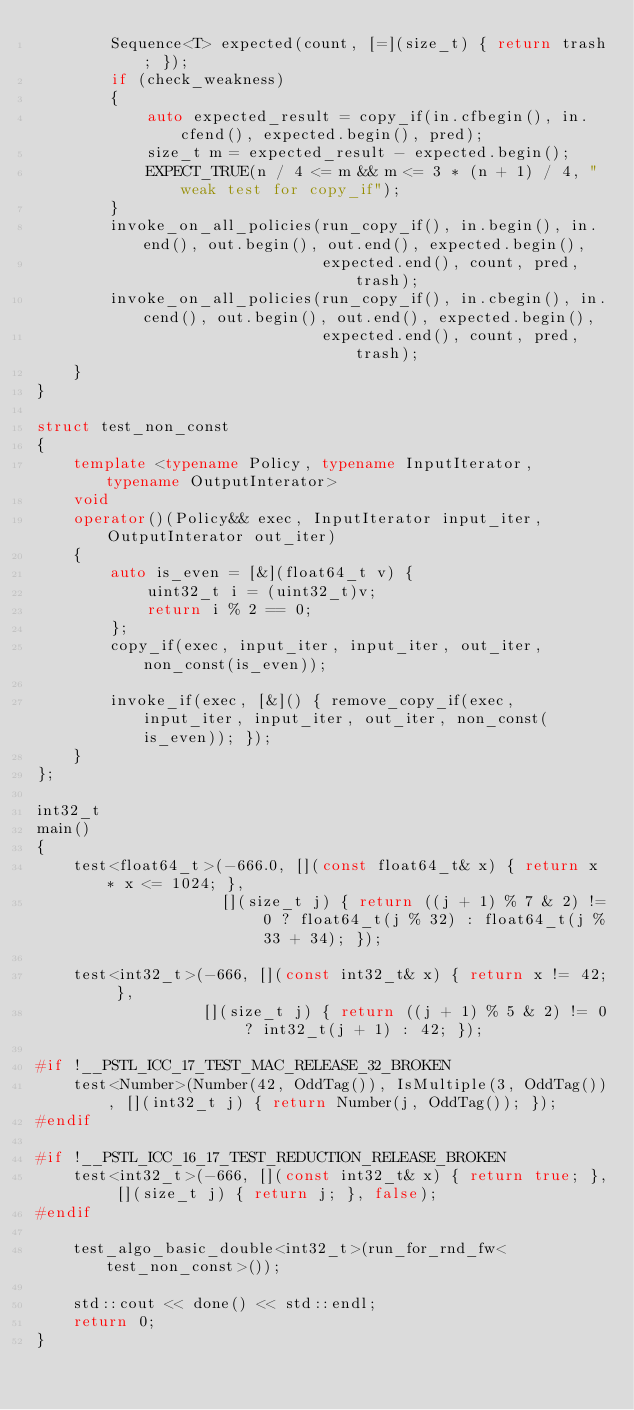<code> <loc_0><loc_0><loc_500><loc_500><_C++_>        Sequence<T> expected(count, [=](size_t) { return trash; });
        if (check_weakness)
        {
            auto expected_result = copy_if(in.cfbegin(), in.cfend(), expected.begin(), pred);
            size_t m = expected_result - expected.begin();
            EXPECT_TRUE(n / 4 <= m && m <= 3 * (n + 1) / 4, "weak test for copy_if");
        }
        invoke_on_all_policies(run_copy_if(), in.begin(), in.end(), out.begin(), out.end(), expected.begin(),
                               expected.end(), count, pred, trash);
        invoke_on_all_policies(run_copy_if(), in.cbegin(), in.cend(), out.begin(), out.end(), expected.begin(),
                               expected.end(), count, pred, trash);
    }
}

struct test_non_const
{
    template <typename Policy, typename InputIterator, typename OutputInterator>
    void
    operator()(Policy&& exec, InputIterator input_iter, OutputInterator out_iter)
    {
        auto is_even = [&](float64_t v) {
            uint32_t i = (uint32_t)v;
            return i % 2 == 0;
        };
        copy_if(exec, input_iter, input_iter, out_iter, non_const(is_even));

        invoke_if(exec, [&]() { remove_copy_if(exec, input_iter, input_iter, out_iter, non_const(is_even)); });
    }
};

int32_t
main()
{
    test<float64_t>(-666.0, [](const float64_t& x) { return x * x <= 1024; },
                    [](size_t j) { return ((j + 1) % 7 & 2) != 0 ? float64_t(j % 32) : float64_t(j % 33 + 34); });

    test<int32_t>(-666, [](const int32_t& x) { return x != 42; },
                  [](size_t j) { return ((j + 1) % 5 & 2) != 0 ? int32_t(j + 1) : 42; });

#if !__PSTL_ICC_17_TEST_MAC_RELEASE_32_BROKEN
    test<Number>(Number(42, OddTag()), IsMultiple(3, OddTag()), [](int32_t j) { return Number(j, OddTag()); });
#endif

#if !__PSTL_ICC_16_17_TEST_REDUCTION_RELEASE_BROKEN
    test<int32_t>(-666, [](const int32_t& x) { return true; }, [](size_t j) { return j; }, false);
#endif

    test_algo_basic_double<int32_t>(run_for_rnd_fw<test_non_const>());

    std::cout << done() << std::endl;
    return 0;
}
</code> 